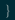Convert code to text. <code><loc_0><loc_0><loc_500><loc_500><_Lua_>}
</code> 